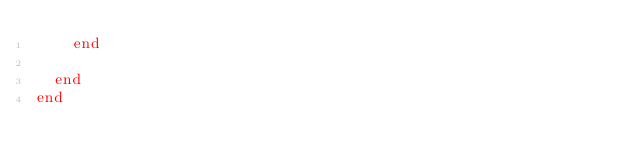Convert code to text. <code><loc_0><loc_0><loc_500><loc_500><_Crystal_>    end

  end
end

</code> 